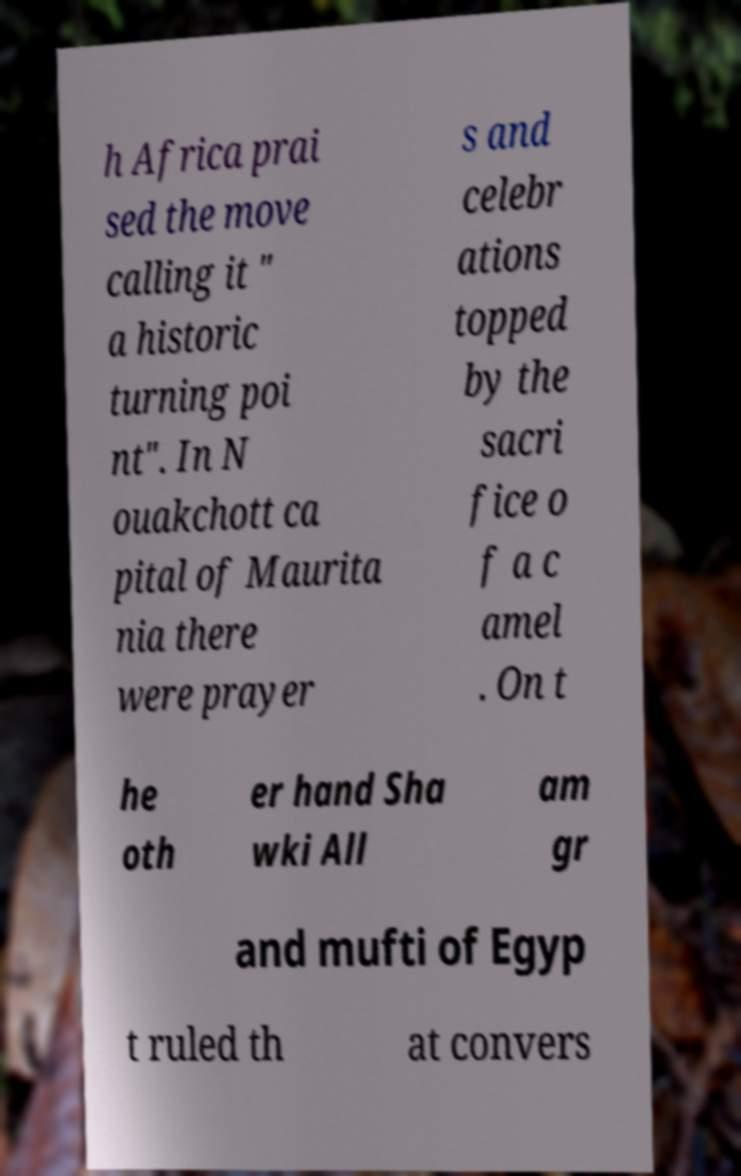I need the written content from this picture converted into text. Can you do that? h Africa prai sed the move calling it " a historic turning poi nt". In N ouakchott ca pital of Maurita nia there were prayer s and celebr ations topped by the sacri fice o f a c amel . On t he oth er hand Sha wki All am gr and mufti of Egyp t ruled th at convers 